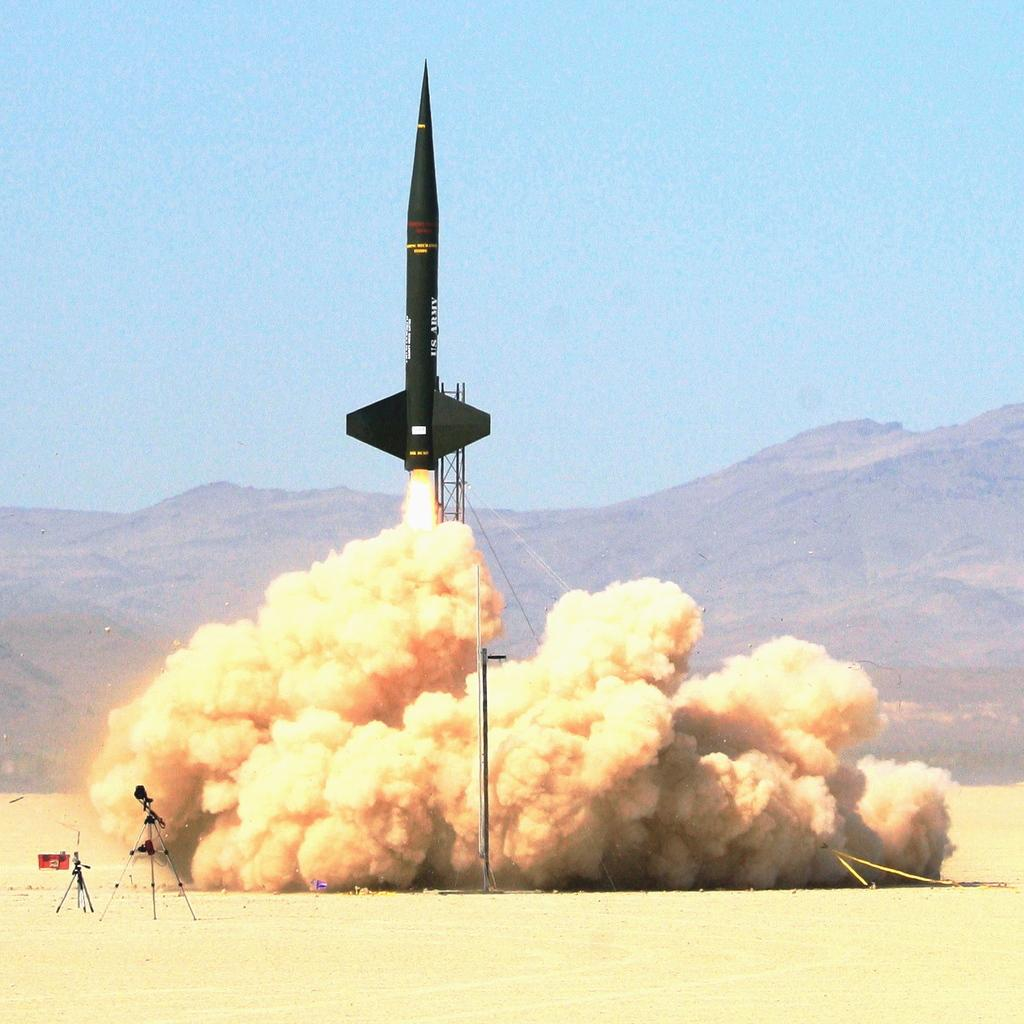What is the main subject of the image? There is a rocket in the image. What can be seen in the background of the image? The sky is visible in the image. What is the result of the rocket's launch in the image? There is smoke in the image as a result of the rocket's launch. What type of terrain is visible in the image? There are mountains in the image. What is visible at the bottom of the image? The ground is visible in the image. What type of journey does the representative take in the image? There is no representative present in the image, and therefore no such journey can be observed. How does the rocket roll in the image? The rocket does not roll in the image; it is launched vertically. 